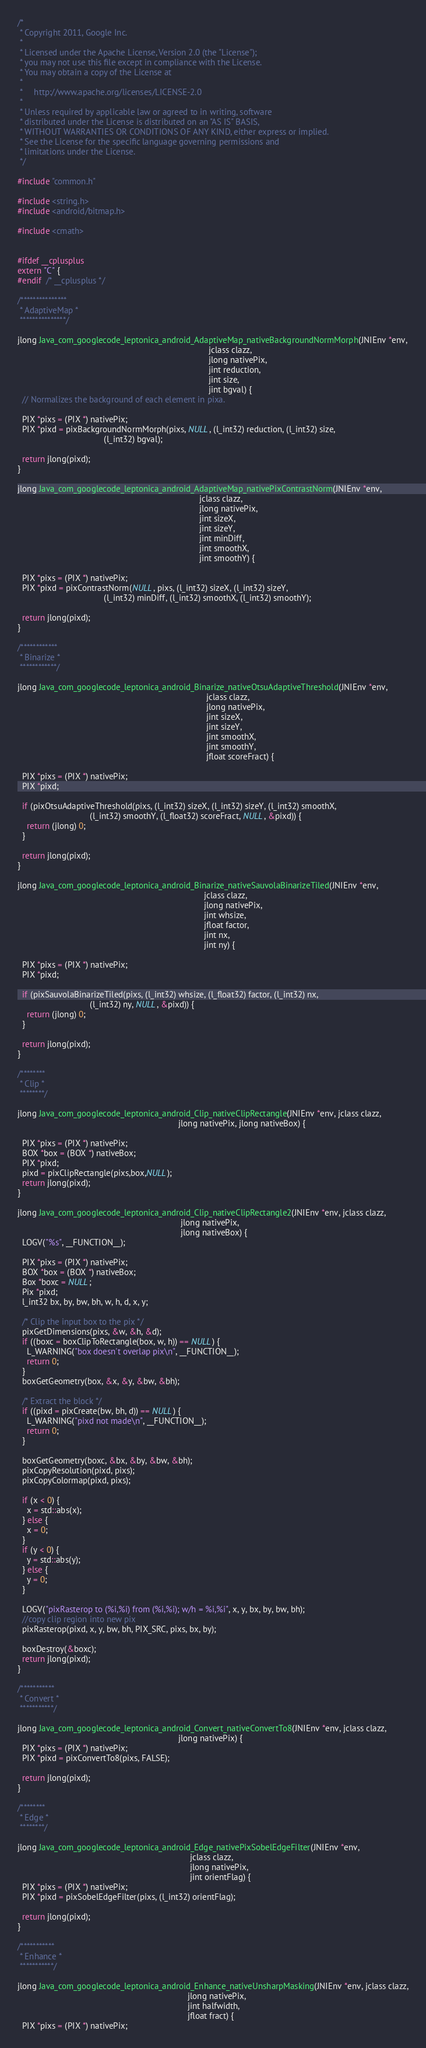Convert code to text. <code><loc_0><loc_0><loc_500><loc_500><_C++_>/*
 * Copyright 2011, Google Inc.
 *
 * Licensed under the Apache License, Version 2.0 (the "License");
 * you may not use this file except in compliance with the License.
 * You may obtain a copy of the License at
 *
 *     http://www.apache.org/licenses/LICENSE-2.0
 *
 * Unless required by applicable law or agreed to in writing, software
 * distributed under the License is distributed on an "AS IS" BASIS,
 * WITHOUT WARRANTIES OR CONDITIONS OF ANY KIND, either express or implied.
 * See the License for the specific language governing permissions and
 * limitations under the License.
 */

#include "common.h"

#include <string.h>
#include <android/bitmap.h>

#include <cmath>


#ifdef __cplusplus
extern "C" {
#endif  /* __cplusplus */

/***************
 * AdaptiveMap *
 ***************/

jlong Java_com_googlecode_leptonica_android_AdaptiveMap_nativeBackgroundNormMorph(JNIEnv *env,
                                                                                  jclass clazz,
                                                                                  jlong nativePix,
                                                                                  jint reduction,
                                                                                  jint size,
                                                                                  jint bgval) {
  // Normalizes the background of each element in pixa.

  PIX *pixs = (PIX *) nativePix;
  PIX *pixd = pixBackgroundNormMorph(pixs, NULL, (l_int32) reduction, (l_int32) size,
                                     (l_int32) bgval);

  return jlong(pixd);
}

jlong Java_com_googlecode_leptonica_android_AdaptiveMap_nativePixContrastNorm(JNIEnv *env,
                                                                              jclass clazz,
                                                                              jlong nativePix,
                                                                              jint sizeX,
                                                                              jint sizeY,
                                                                              jint minDiff,
                                                                              jint smoothX,
                                                                              jint smoothY) {

  PIX *pixs = (PIX *) nativePix;
  PIX *pixd = pixContrastNorm(NULL, pixs, (l_int32) sizeX, (l_int32) sizeY,
                                     (l_int32) minDiff, (l_int32) smoothX, (l_int32) smoothY);

  return jlong(pixd);
}

/************
 * Binarize *
 ************/

jlong Java_com_googlecode_leptonica_android_Binarize_nativeOtsuAdaptiveThreshold(JNIEnv *env,
                                                                                 jclass clazz,
                                                                                 jlong nativePix,
                                                                                 jint sizeX,
                                                                                 jint sizeY,
                                                                                 jint smoothX,
                                                                                 jint smoothY,
                                                                                 jfloat scoreFract) {

  PIX *pixs = (PIX *) nativePix;
  PIX *pixd;

  if (pixOtsuAdaptiveThreshold(pixs, (l_int32) sizeX, (l_int32) sizeY, (l_int32) smoothX,
                               (l_int32) smoothY, (l_float32) scoreFract, NULL, &pixd)) {
    return (jlong) 0;
  }

  return jlong(pixd);
}

jlong Java_com_googlecode_leptonica_android_Binarize_nativeSauvolaBinarizeTiled(JNIEnv *env,
                                                                                jclass clazz,
                                                                                jlong nativePix,
                                                                                jint whsize,
                                                                                jfloat factor,
                                                                                jint nx,
                                                                                jint ny) {

  PIX *pixs = (PIX *) nativePix;
  PIX *pixd;

  if (pixSauvolaBinarizeTiled(pixs, (l_int32) whsize, (l_float32) factor, (l_int32) nx,
                               (l_int32) ny, NULL, &pixd)) {
    return (jlong) 0;
  }

  return jlong(pixd);
}

/********
 * Clip *
 ********/

jlong Java_com_googlecode_leptonica_android_Clip_nativeClipRectangle(JNIEnv *env, jclass clazz,
                                                                     jlong nativePix, jlong nativeBox) {

  PIX *pixs = (PIX *) nativePix;
  BOX *box = (BOX *) nativeBox;
  PIX *pixd;
  pixd = pixClipRectangle(pixs,box,NULL);
  return jlong(pixd);
}

jlong Java_com_googlecode_leptonica_android_Clip_nativeClipRectangle2(JNIEnv *env, jclass clazz,
                                                                      jlong nativePix,
                                                                      jlong nativeBox) {
  LOGV("%s", __FUNCTION__);

  PIX *pixs = (PIX *) nativePix;
  BOX *box = (BOX *) nativeBox;
  Box *boxc = NULL;
  Pix *pixd;
  l_int32 bx, by, bw, bh, w, h, d, x, y;

  /* Clip the input box to the pix */
  pixGetDimensions(pixs, &w, &h, &d);
  if ((boxc = boxClipToRectangle(box, w, h)) == NULL) {
    L_WARNING("box doesn't overlap pix\n", __FUNCTION__);
    return 0;
  }
  boxGetGeometry(box, &x, &y, &bw, &bh);

  /* Extract the block */
  if ((pixd = pixCreate(bw, bh, d)) == NULL) {
    L_WARNING("pixd not made\n", __FUNCTION__);
    return 0;
  }

  boxGetGeometry(boxc, &bx, &by, &bw, &bh);
  pixCopyResolution(pixd, pixs);
  pixCopyColormap(pixd, pixs);

  if (x < 0) {
    x = std::abs(x);
  } else {
    x = 0;
  }
  if (y < 0) {
    y = std::abs(y);
  } else {
    y = 0;
  }

  LOGV("pixRasterop to (%i,%i) from (%i,%i); w/h = %i,%i", x, y, bx, by, bw, bh);
  //copy clip region into new pix
  pixRasterop(pixd, x, y, bw, bh, PIX_SRC, pixs, bx, by);

  boxDestroy(&boxc);
  return jlong(pixd);
}

/***********
 * Convert *
 ***********/

jlong Java_com_googlecode_leptonica_android_Convert_nativeConvertTo8(JNIEnv *env, jclass clazz,
                                                                     jlong nativePix) {
  PIX *pixs = (PIX *) nativePix;
  PIX *pixd = pixConvertTo8(pixs, FALSE);

  return jlong(pixd);
}

/********
 * Edge *
 ********/

jlong Java_com_googlecode_leptonica_android_Edge_nativePixSobelEdgeFilter(JNIEnv *env,
                                                                          jclass clazz,
                                                                          jlong nativePix,
                                                                          jint orientFlag) {
  PIX *pixs = (PIX *) nativePix;
  PIX *pixd = pixSobelEdgeFilter(pixs, (l_int32) orientFlag);

  return jlong(pixd);
}

/***********
 * Enhance *
 ***********/

jlong Java_com_googlecode_leptonica_android_Enhance_nativeUnsharpMasking(JNIEnv *env, jclass clazz,
                                                                         jlong nativePix,
                                                                         jint halfwidth,
                                                                         jfloat fract) {
  PIX *pixs = (PIX *) nativePix;</code> 